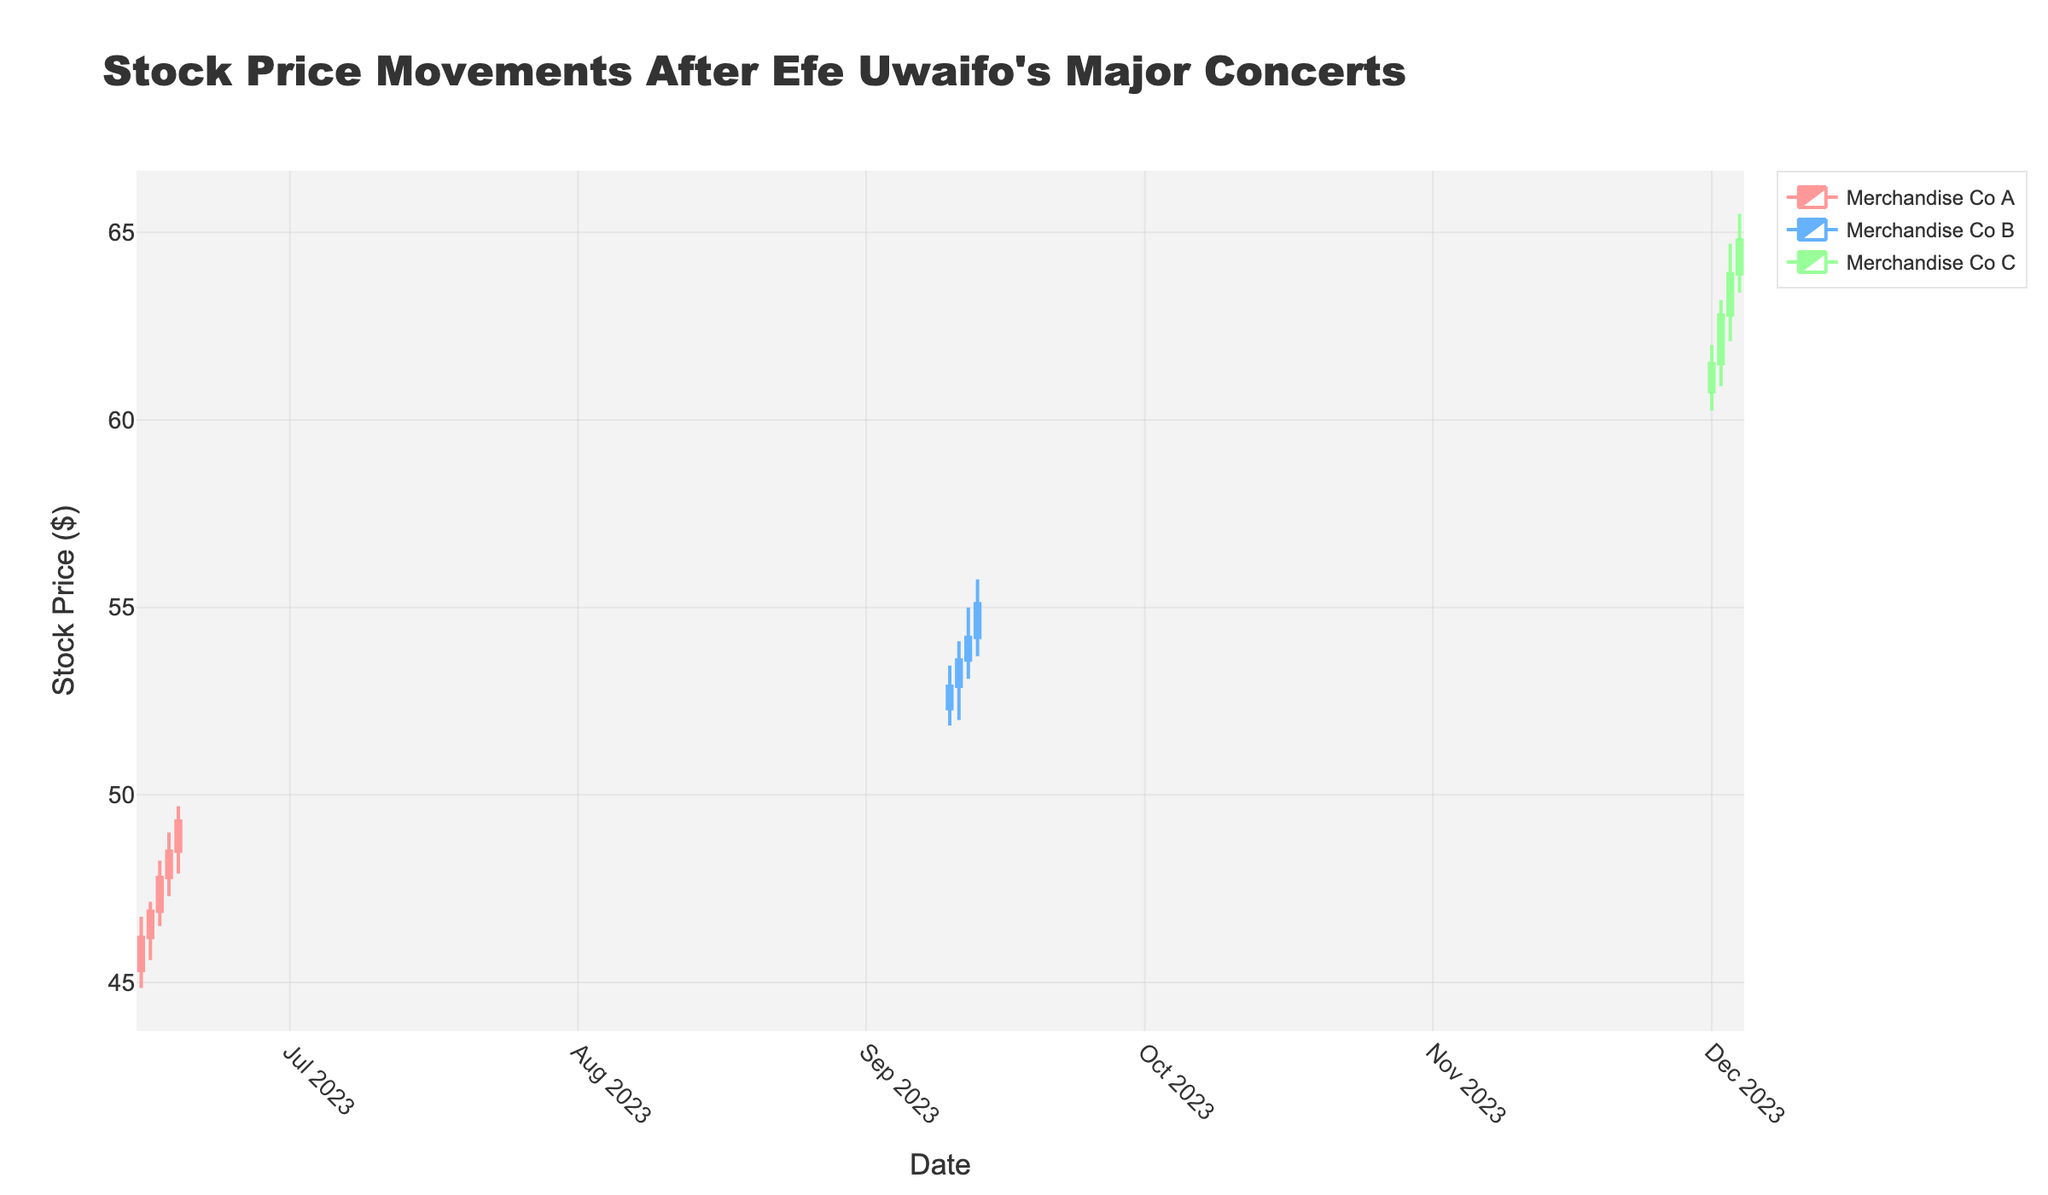what is the title of the figure? The title is displayed at the top of the figure. It is often descriptive and provides an overview of the data representation in the plot. Here, the title is "Stock Price Movements After Efe Uwaifo's Major Concerts".
Answer: Stock Price Movements After Efe Uwaifo's Major Concerts What is the date range for the stock data of Merchandise Co A? By looking at the dates on the x-axis and associating them with the company's data points, we see the date range for Merchandise Co A starts at "2023-06-15" and ends at "2023-06-19".
Answer: 2023-06-15 to 2023-06-19 Which company has the highest closing price in the given data? To determine this, we compare the closing prices for each given date across all companies. The highest closing price is $64.80 for Merchandise Co C on 2023-12-04.
Answer: Merchandise Co C Which company shows the largest increase in closing price from the first to the last date of its data? Calculate the increase for each company by subtracting the first day's closing price from the last day's closing price. For Merchandise Co A: $49.30 - $46.20 = $3.10, for Merchandise Co B: $55.10 - $52.90 = $2.20, for Merchandise Co C: $64.80 - $61.50 = $3.30. The largest increase is $3.30 for Merchandise Co C.
Answer: Merchandise Co C What is the average closing price of Merchandise Co B over the given dates? Calculate the average by summing the closing prices for all dates pertaining to Merchandise Co B and dividing by the number of dates. The sum is $52.90 + $53.60 + $54.20 + $55.10 = $215.80. There are 4 dates, so the average is $215.80 / 4 = $53.95.
Answer: $53.95 Which company had the highest trading volume, and what was its volume? We can find the highest volume by comparing volumes for all dates across companies. The highest volume is 240200 for Merchandise Co C on 2023-12-04.
Answer: Merchandise Co C, 240200 On what date did Merchandise Co B have the highest price fluctuation (difference between high and low prices)? Calculate the difference between high and low prices for each date. The fluctuations are: 1.6 on 2023-09-10, 2.1 on 2023-09-11, 1.9 on 2023-09-12, and 2.05 on 2023-09-13. The highest fluctuation is $2.1 on 2023-09-11.
Answer: 2023-09-11 Which company shows the most consistent increase in closing prices over its date range? Observe the trend in closing prices over the dates for each company. Merchandise Co A displays continuous increase from $46.20 to $49.30 for all consecutive dates from 2023-06-15 to 2023-06-19. Merchandise Co B and Merchandise Co C do not have such consistent trends.
Answer: Merchandise Co A 